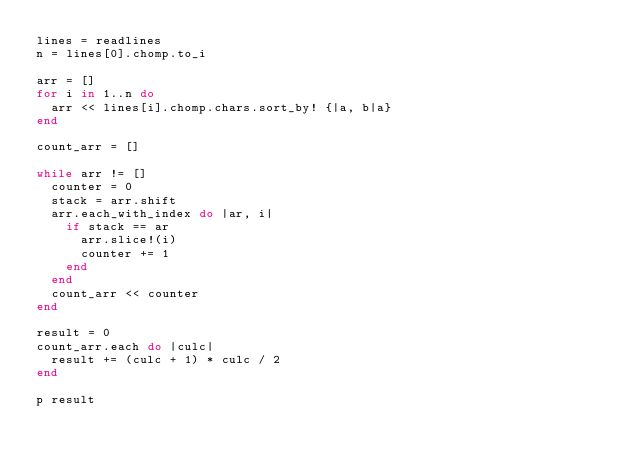Convert code to text. <code><loc_0><loc_0><loc_500><loc_500><_Ruby_>lines = readlines
n = lines[0].chomp.to_i

arr = []
for i in 1..n do
  arr << lines[i].chomp.chars.sort_by! {|a, b|a}
end

count_arr = []

while arr != []
  counter = 0
  stack = arr.shift
  arr.each_with_index do |ar, i|
    if stack == ar
      arr.slice!(i)
      counter += 1
    end
  end
  count_arr << counter
end

result = 0
count_arr.each do |culc|
  result += (culc + 1) * culc / 2
end

p result</code> 